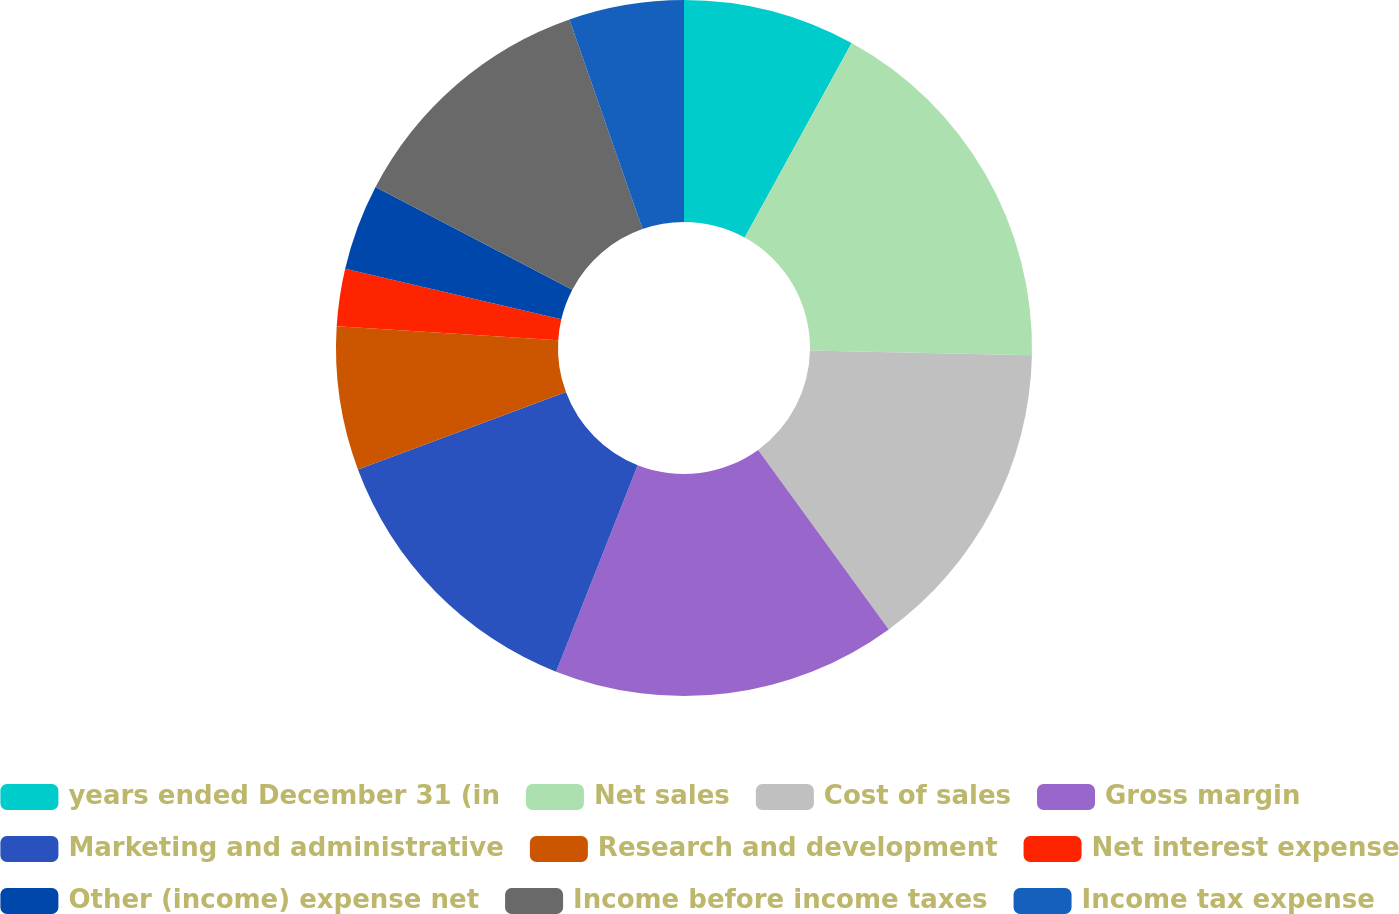Convert chart to OTSL. <chart><loc_0><loc_0><loc_500><loc_500><pie_chart><fcel>years ended December 31 (in<fcel>Net sales<fcel>Cost of sales<fcel>Gross margin<fcel>Marketing and administrative<fcel>Research and development<fcel>Net interest expense<fcel>Other (income) expense net<fcel>Income before income taxes<fcel>Income tax expense<nl><fcel>8.0%<fcel>17.33%<fcel>14.66%<fcel>16.0%<fcel>13.33%<fcel>6.67%<fcel>2.67%<fcel>4.0%<fcel>12.0%<fcel>5.34%<nl></chart> 